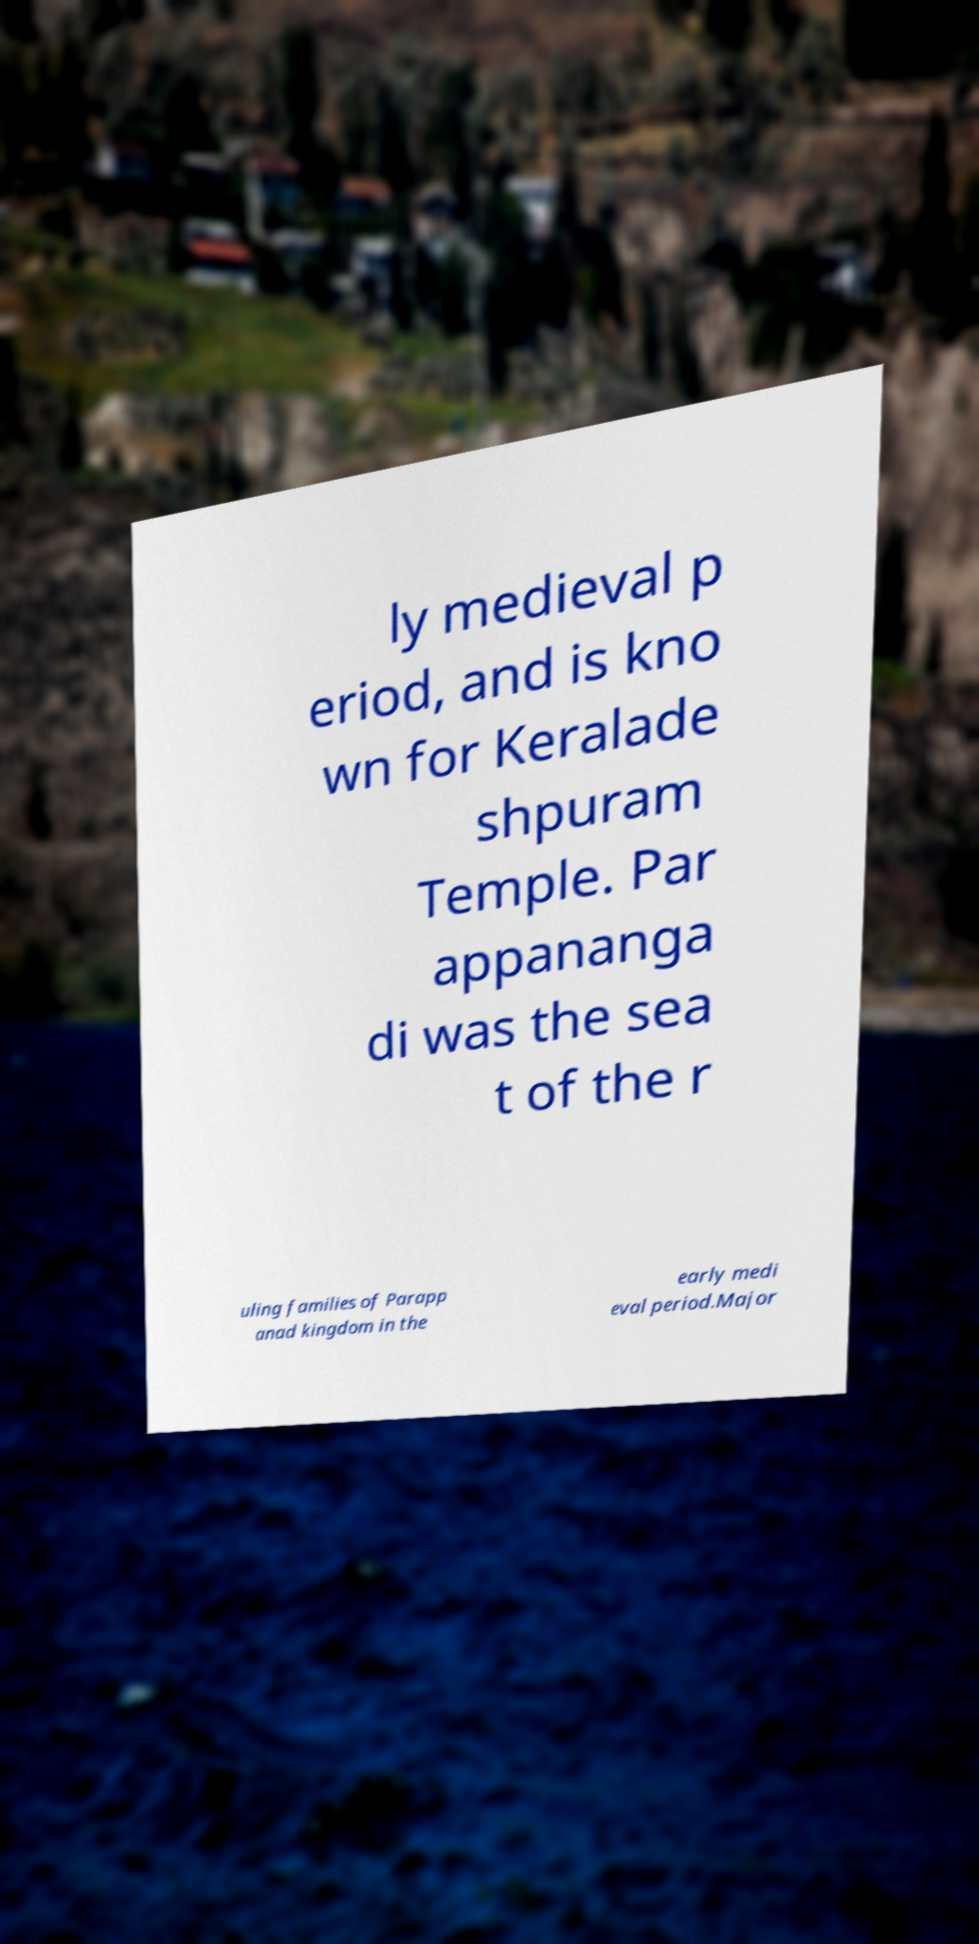I need the written content from this picture converted into text. Can you do that? ly medieval p eriod, and is kno wn for Keralade shpuram Temple. Par appananga di was the sea t of the r uling families of Parapp anad kingdom in the early medi eval period.Major 